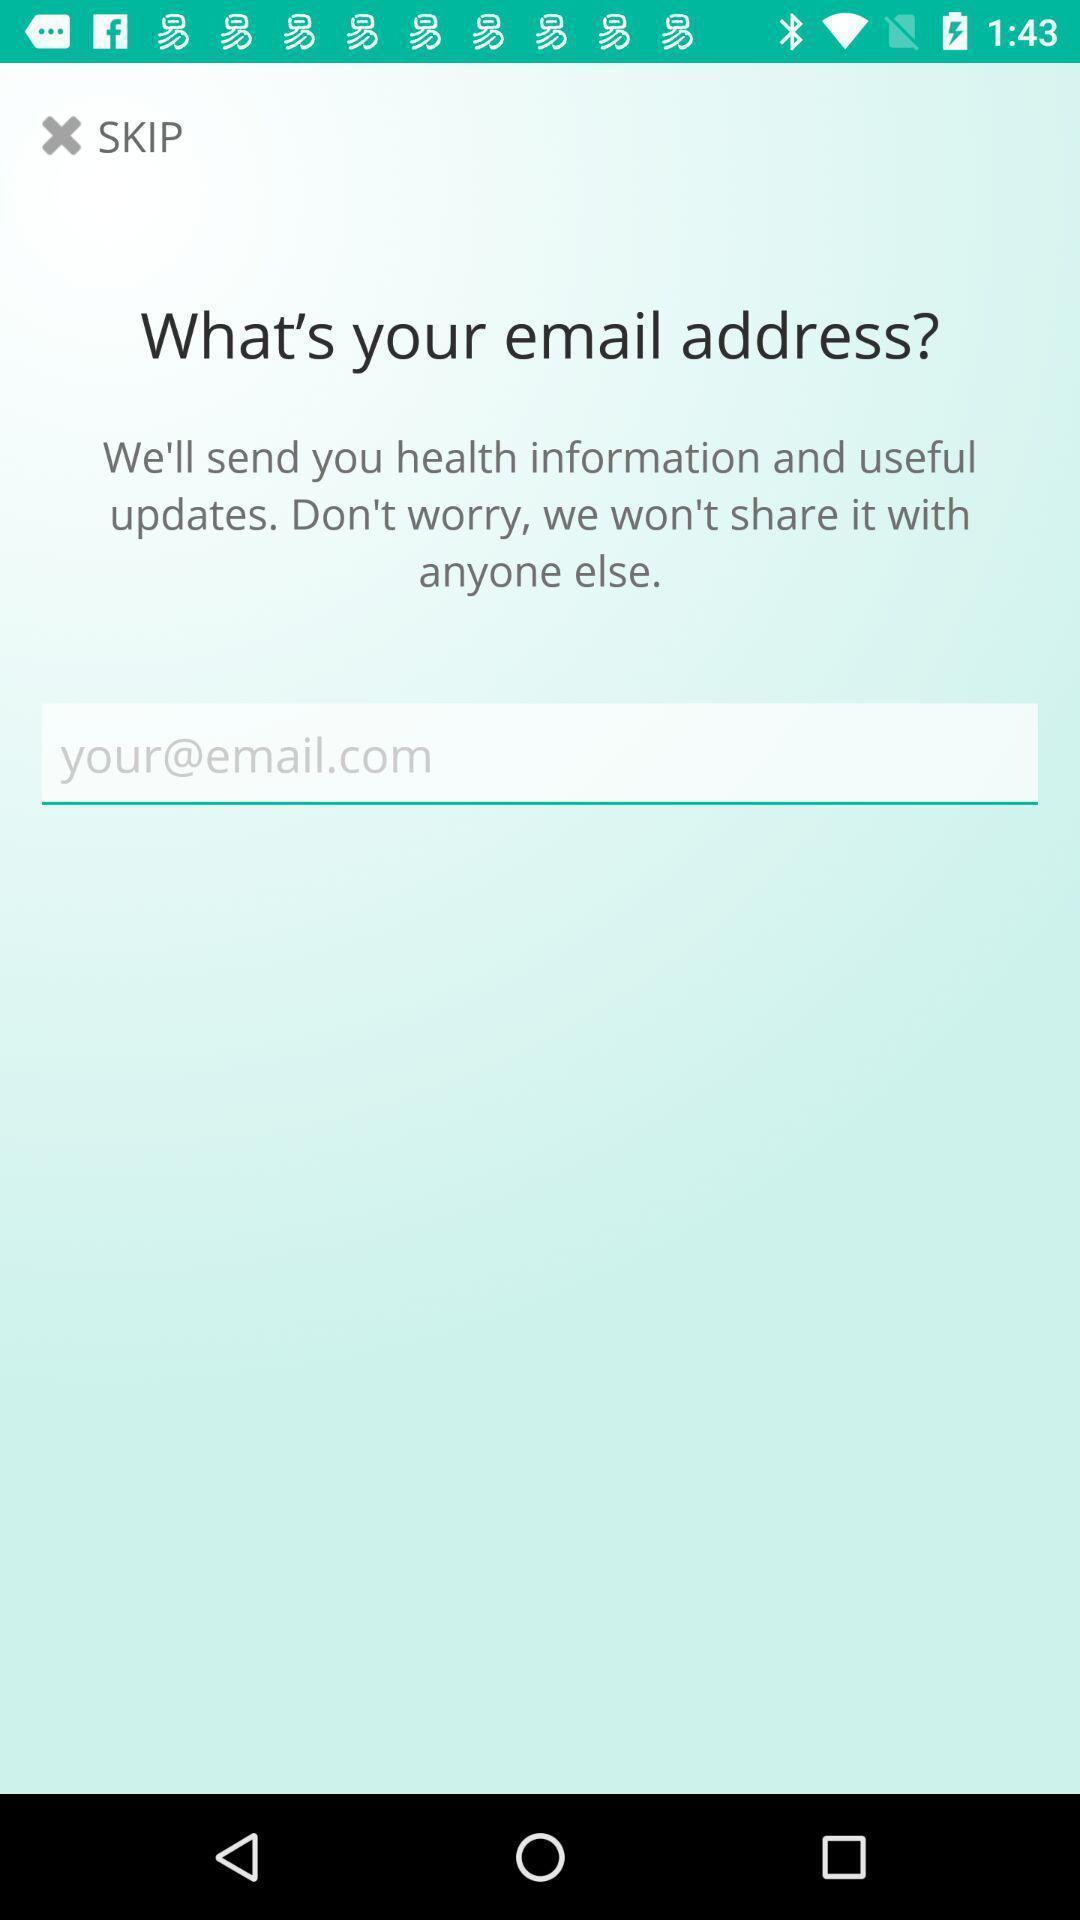Please provide a description for this image. Page having email text box for notifications. 